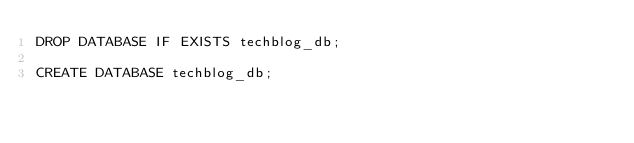Convert code to text. <code><loc_0><loc_0><loc_500><loc_500><_SQL_>DROP DATABASE IF EXISTS techblog_db;

CREATE DATABASE techblog_db;
</code> 